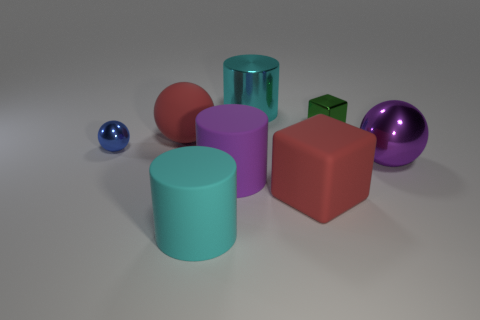Subtract all gray blocks. How many cyan cylinders are left? 2 Subtract all matte cylinders. How many cylinders are left? 1 Add 1 tiny red matte objects. How many objects exist? 9 Subtract all cylinders. How many objects are left? 5 Subtract all cyan spheres. Subtract all red cylinders. How many spheres are left? 3 Subtract all large matte spheres. Subtract all big purple shiny objects. How many objects are left? 6 Add 3 cyan objects. How many cyan objects are left? 5 Add 8 big red things. How many big red things exist? 10 Subtract 0 red cylinders. How many objects are left? 8 